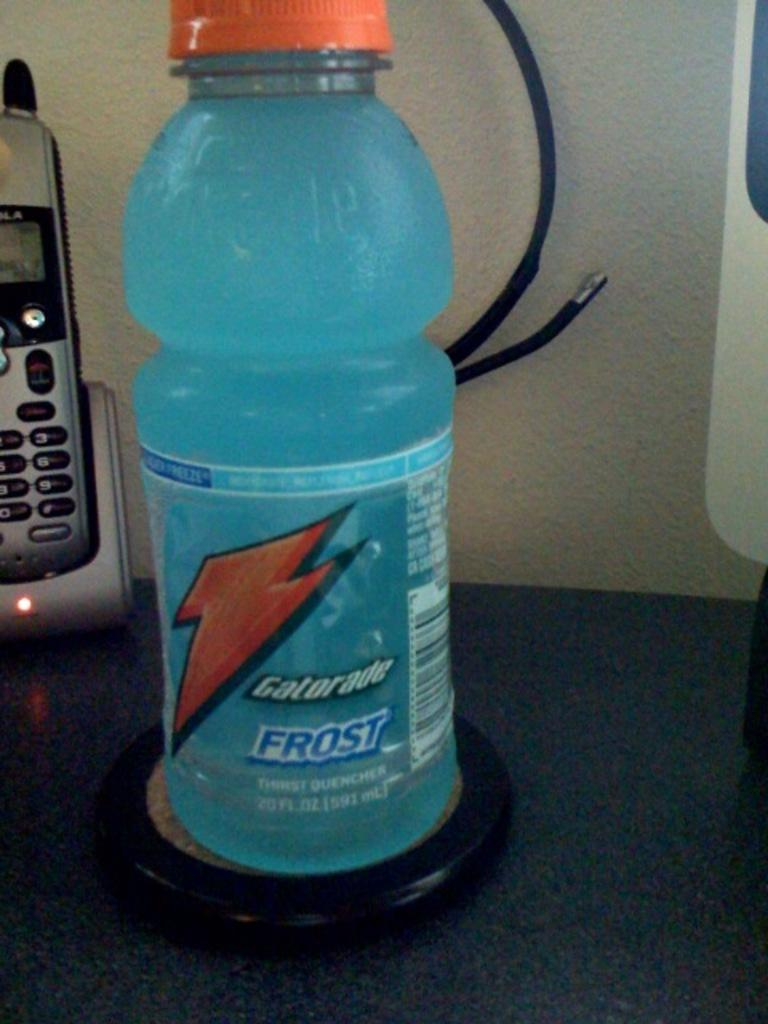Provide a one-sentence caption for the provided image. Frost Gatorade looking cold sits in front of a silver home phone on a counter. 